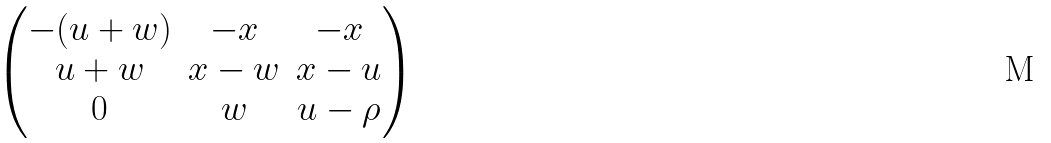<formula> <loc_0><loc_0><loc_500><loc_500>\begin{pmatrix} - ( u + w ) & - x & - x \\ u + w & x - w & x - u \\ 0 & w & u - \rho \end{pmatrix}</formula> 